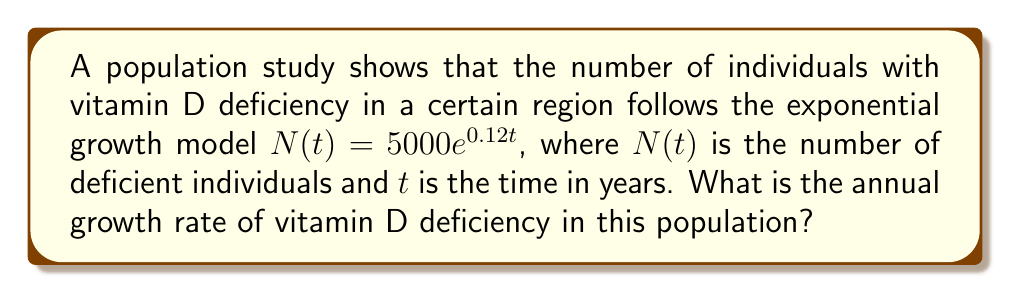Could you help me with this problem? To determine the annual growth rate from an exponential growth model, we follow these steps:

1) The general form of exponential growth is:

   $$N(t) = N_0e^{rt}$$

   where $N_0$ is the initial population, $r$ is the growth rate, and $t$ is time.

2) In our case, we have:

   $$N(t) = 5000e^{0.12t}$$

3) Comparing this to the general form, we can see that $r = 0.12$.

4) However, $r$ represents the continuous growth rate. To find the annual growth rate as a percentage, we need to use the formula:

   $$\text{Annual Growth Rate} = (e^r - 1) \times 100\%$$

5) Substituting $r = 0.12$:

   $$\text{Annual Growth Rate} = (e^{0.12} - 1) \times 100\%$$

6) Calculate:
   $$\begin{align*}
   \text{Annual Growth Rate} &= (e^{0.12} - 1) \times 100\% \\
   &= (1.1275 - 1) \times 100\% \\
   &= 0.1275 \times 100\% \\
   &= 12.75\%
   \end{align*}$$

Thus, the annual growth rate of vitamin D deficiency in this population is approximately 12.75%.
Answer: 12.75% 